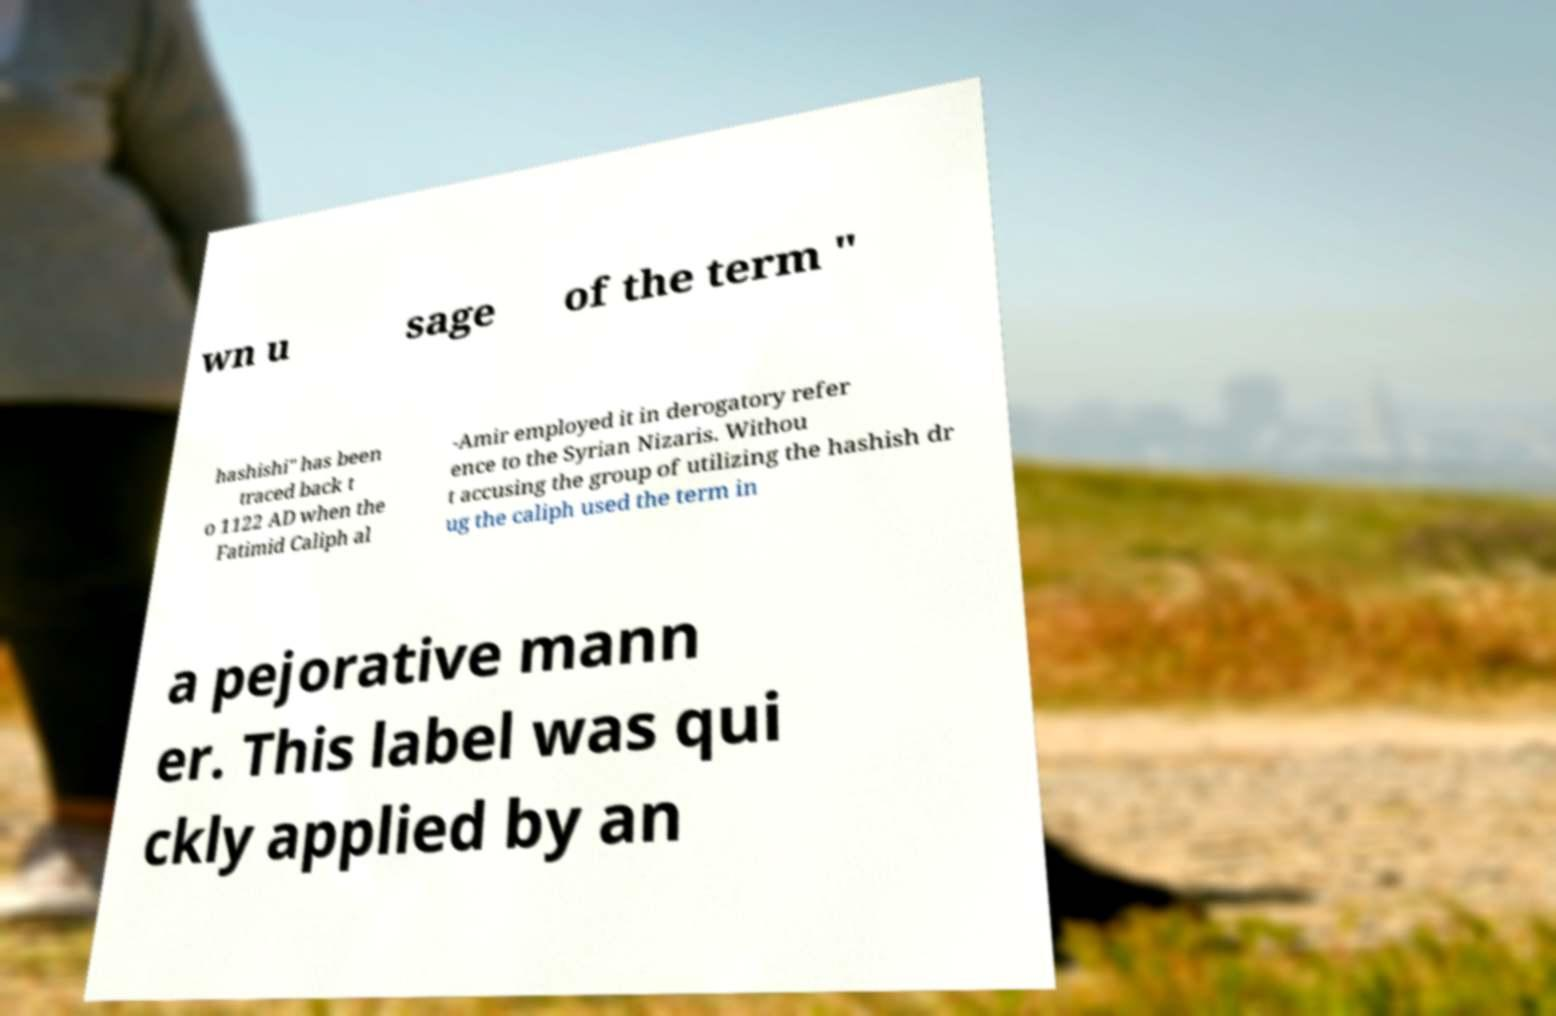Could you assist in decoding the text presented in this image and type it out clearly? wn u sage of the term " hashishi" has been traced back t o 1122 AD when the Fatimid Caliph al -Amir employed it in derogatory refer ence to the Syrian Nizaris. Withou t accusing the group of utilizing the hashish dr ug the caliph used the term in a pejorative mann er. This label was qui ckly applied by an 